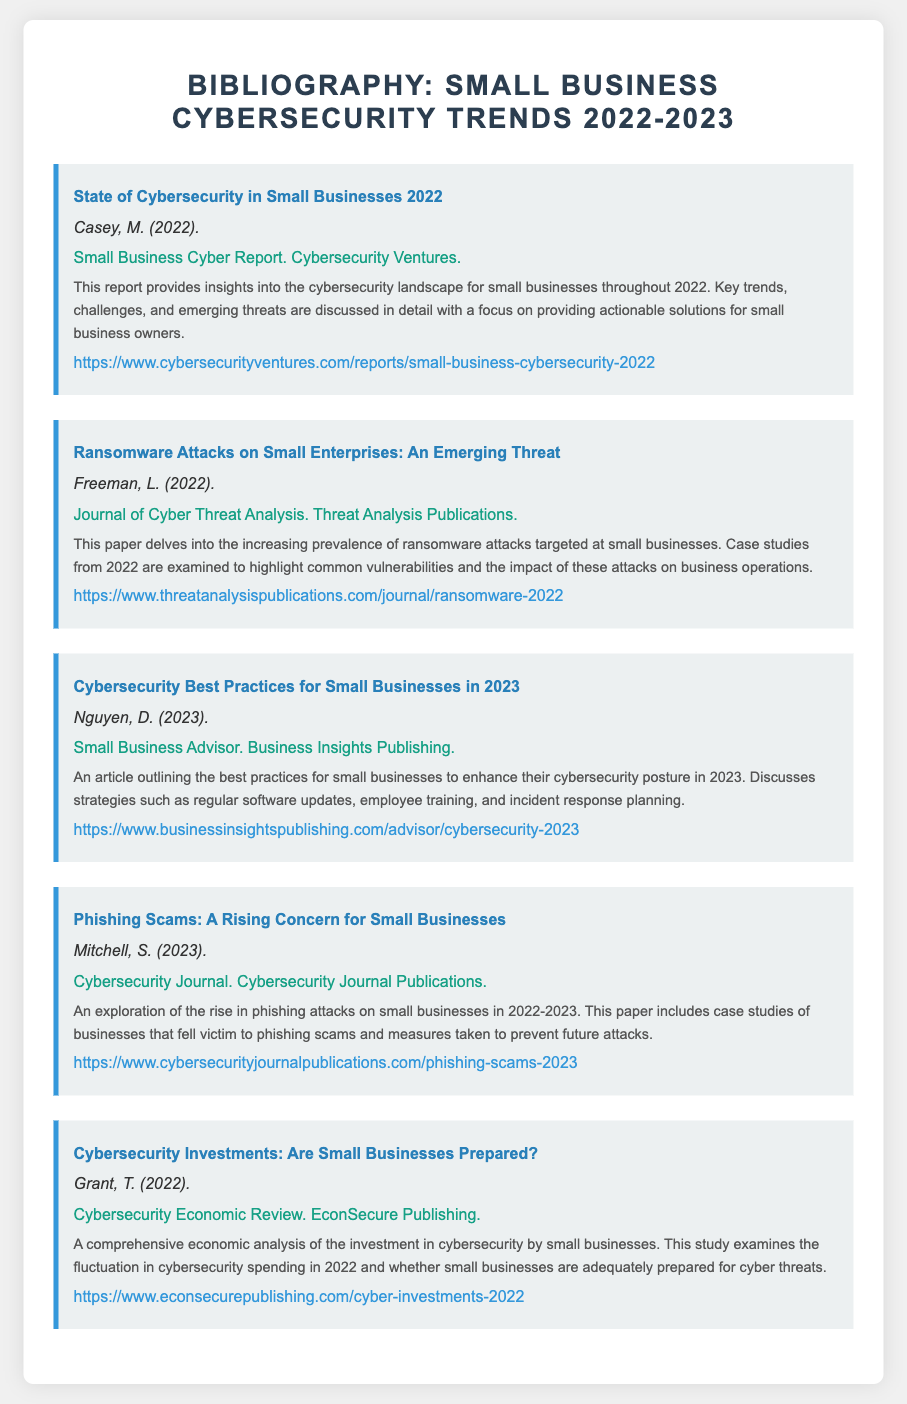What is the title of the first entry? The title of the first entry is about the state of cybersecurity specifically for small businesses in the year mentioned.
Answer: State of Cybersecurity in Small Businesses 2022 Who is the author of the article on phishing scams? The author of the entry discussing phishing scams is a notable contributor to cybersecurity discussions in recent times.
Answer: Mitchell, S What year does the entry on cybersecurity best practices refer to? The entry clearly mentions the strategies that small businesses should adopt in the year following 2022.
Answer: 2023 What type of attacks does Freeman's paper focus on? The paper discusses a specific category of malicious attacks that have been increasing, particularly targeting small businesses in recent years.
Answer: Ransomware attacks What publication features the article on cybersecurity investments? The publication provides insights concerning economic analyses related to cybersecurity funding, particularly for smaller enterprises.
Answer: Cybersecurity Economic Review How many entries are listed in the bibliography? The total number of entries contributes to a comprehensive overview of small business cybersecurity trends during the specified time period.
Answer: Five 